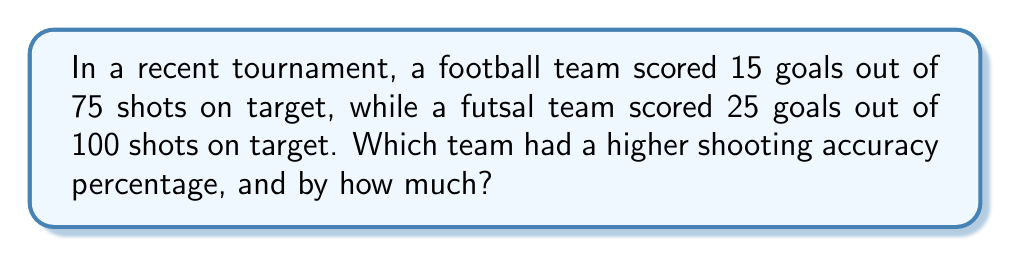Solve this math problem. Let's approach this step-by-step:

1. Calculate the shooting accuracy percentage for the football team:
   $$\text{Football accuracy} = \frac{\text{Goals scored}}{\text{Total shots}} \times 100\%$$
   $$= \frac{15}{75} \times 100\% = 0.2 \times 100\% = 20\%$$

2. Calculate the shooting accuracy percentage for the futsal team:
   $$\text{Futsal accuracy} = \frac{\text{Goals scored}}{\text{Total shots}} \times 100\%$$
   $$= \frac{25}{100} \times 100\% = 0.25 \times 100\% = 25\%$$

3. Compare the two percentages:
   The futsal team has a higher shooting accuracy percentage.

4. Calculate the difference:
   $$\text{Difference} = \text{Futsal accuracy} - \text{Football accuracy}$$
   $$= 25\% - 20\% = 5\%$$

Therefore, the futsal team had a higher shooting accuracy percentage by 5 percentage points.
Answer: Futsal team; 5 percentage points higher 